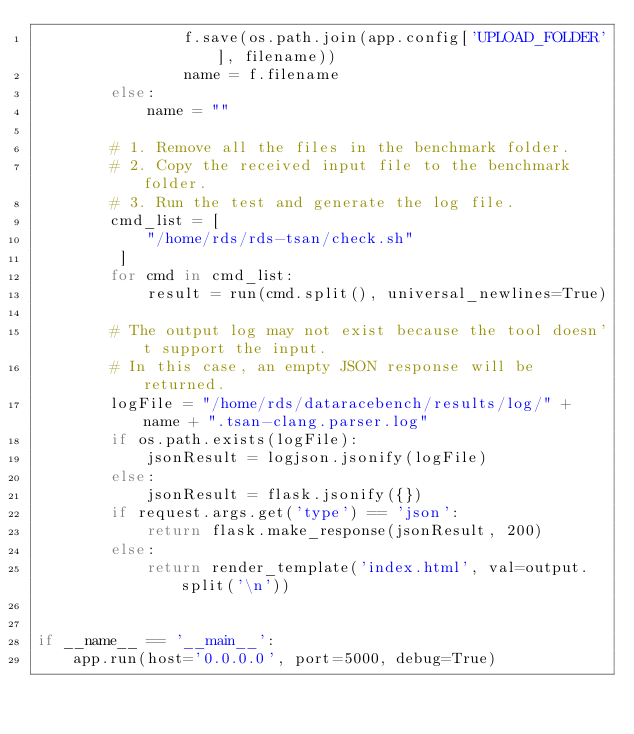<code> <loc_0><loc_0><loc_500><loc_500><_Python_>                f.save(os.path.join(app.config['UPLOAD_FOLDER'], filename))
                name = f.filename
        else:
            name = ""

        # 1. Remove all the files in the benchmark folder.
        # 2. Copy the received input file to the benchmark folder.
        # 3. Run the test and generate the log file.
        cmd_list = [
            "/home/rds/rds-tsan/check.sh"
         ]
        for cmd in cmd_list:
            result = run(cmd.split(), universal_newlines=True)

        # The output log may not exist because the tool doesn't support the input.
        # In this case, an empty JSON response will be returned.
        logFile = "/home/rds/dataracebench/results/log/" + name + ".tsan-clang.parser.log"
        if os.path.exists(logFile):
            jsonResult = logjson.jsonify(logFile)
        else:
            jsonResult = flask.jsonify({})
        if request.args.get('type') == 'json':
            return flask.make_response(jsonResult, 200)
        else:
            return render_template('index.html', val=output.split('\n'))


if __name__ == '__main__':
    app.run(host='0.0.0.0', port=5000, debug=True)
</code> 